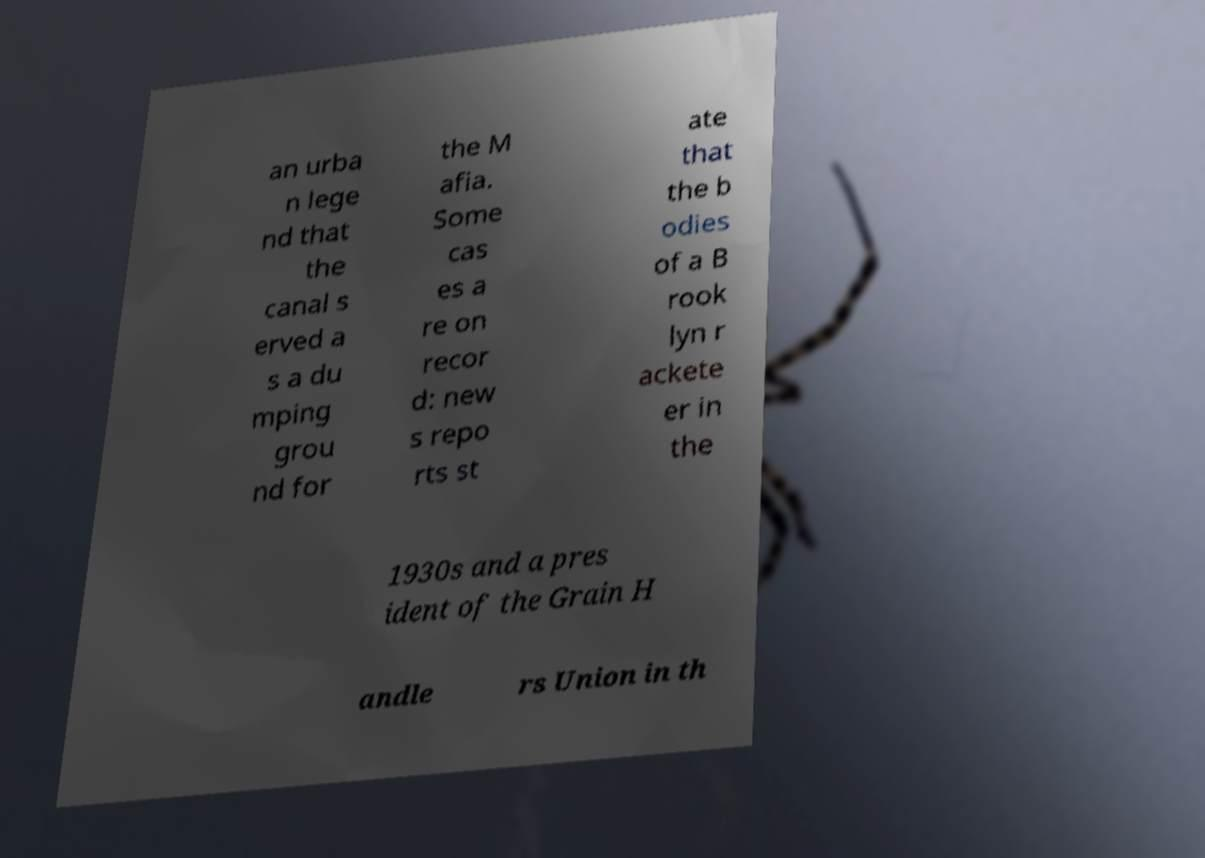What messages or text are displayed in this image? I need them in a readable, typed format. an urba n lege nd that the canal s erved a s a du mping grou nd for the M afia. Some cas es a re on recor d: new s repo rts st ate that the b odies of a B rook lyn r ackete er in the 1930s and a pres ident of the Grain H andle rs Union in th 